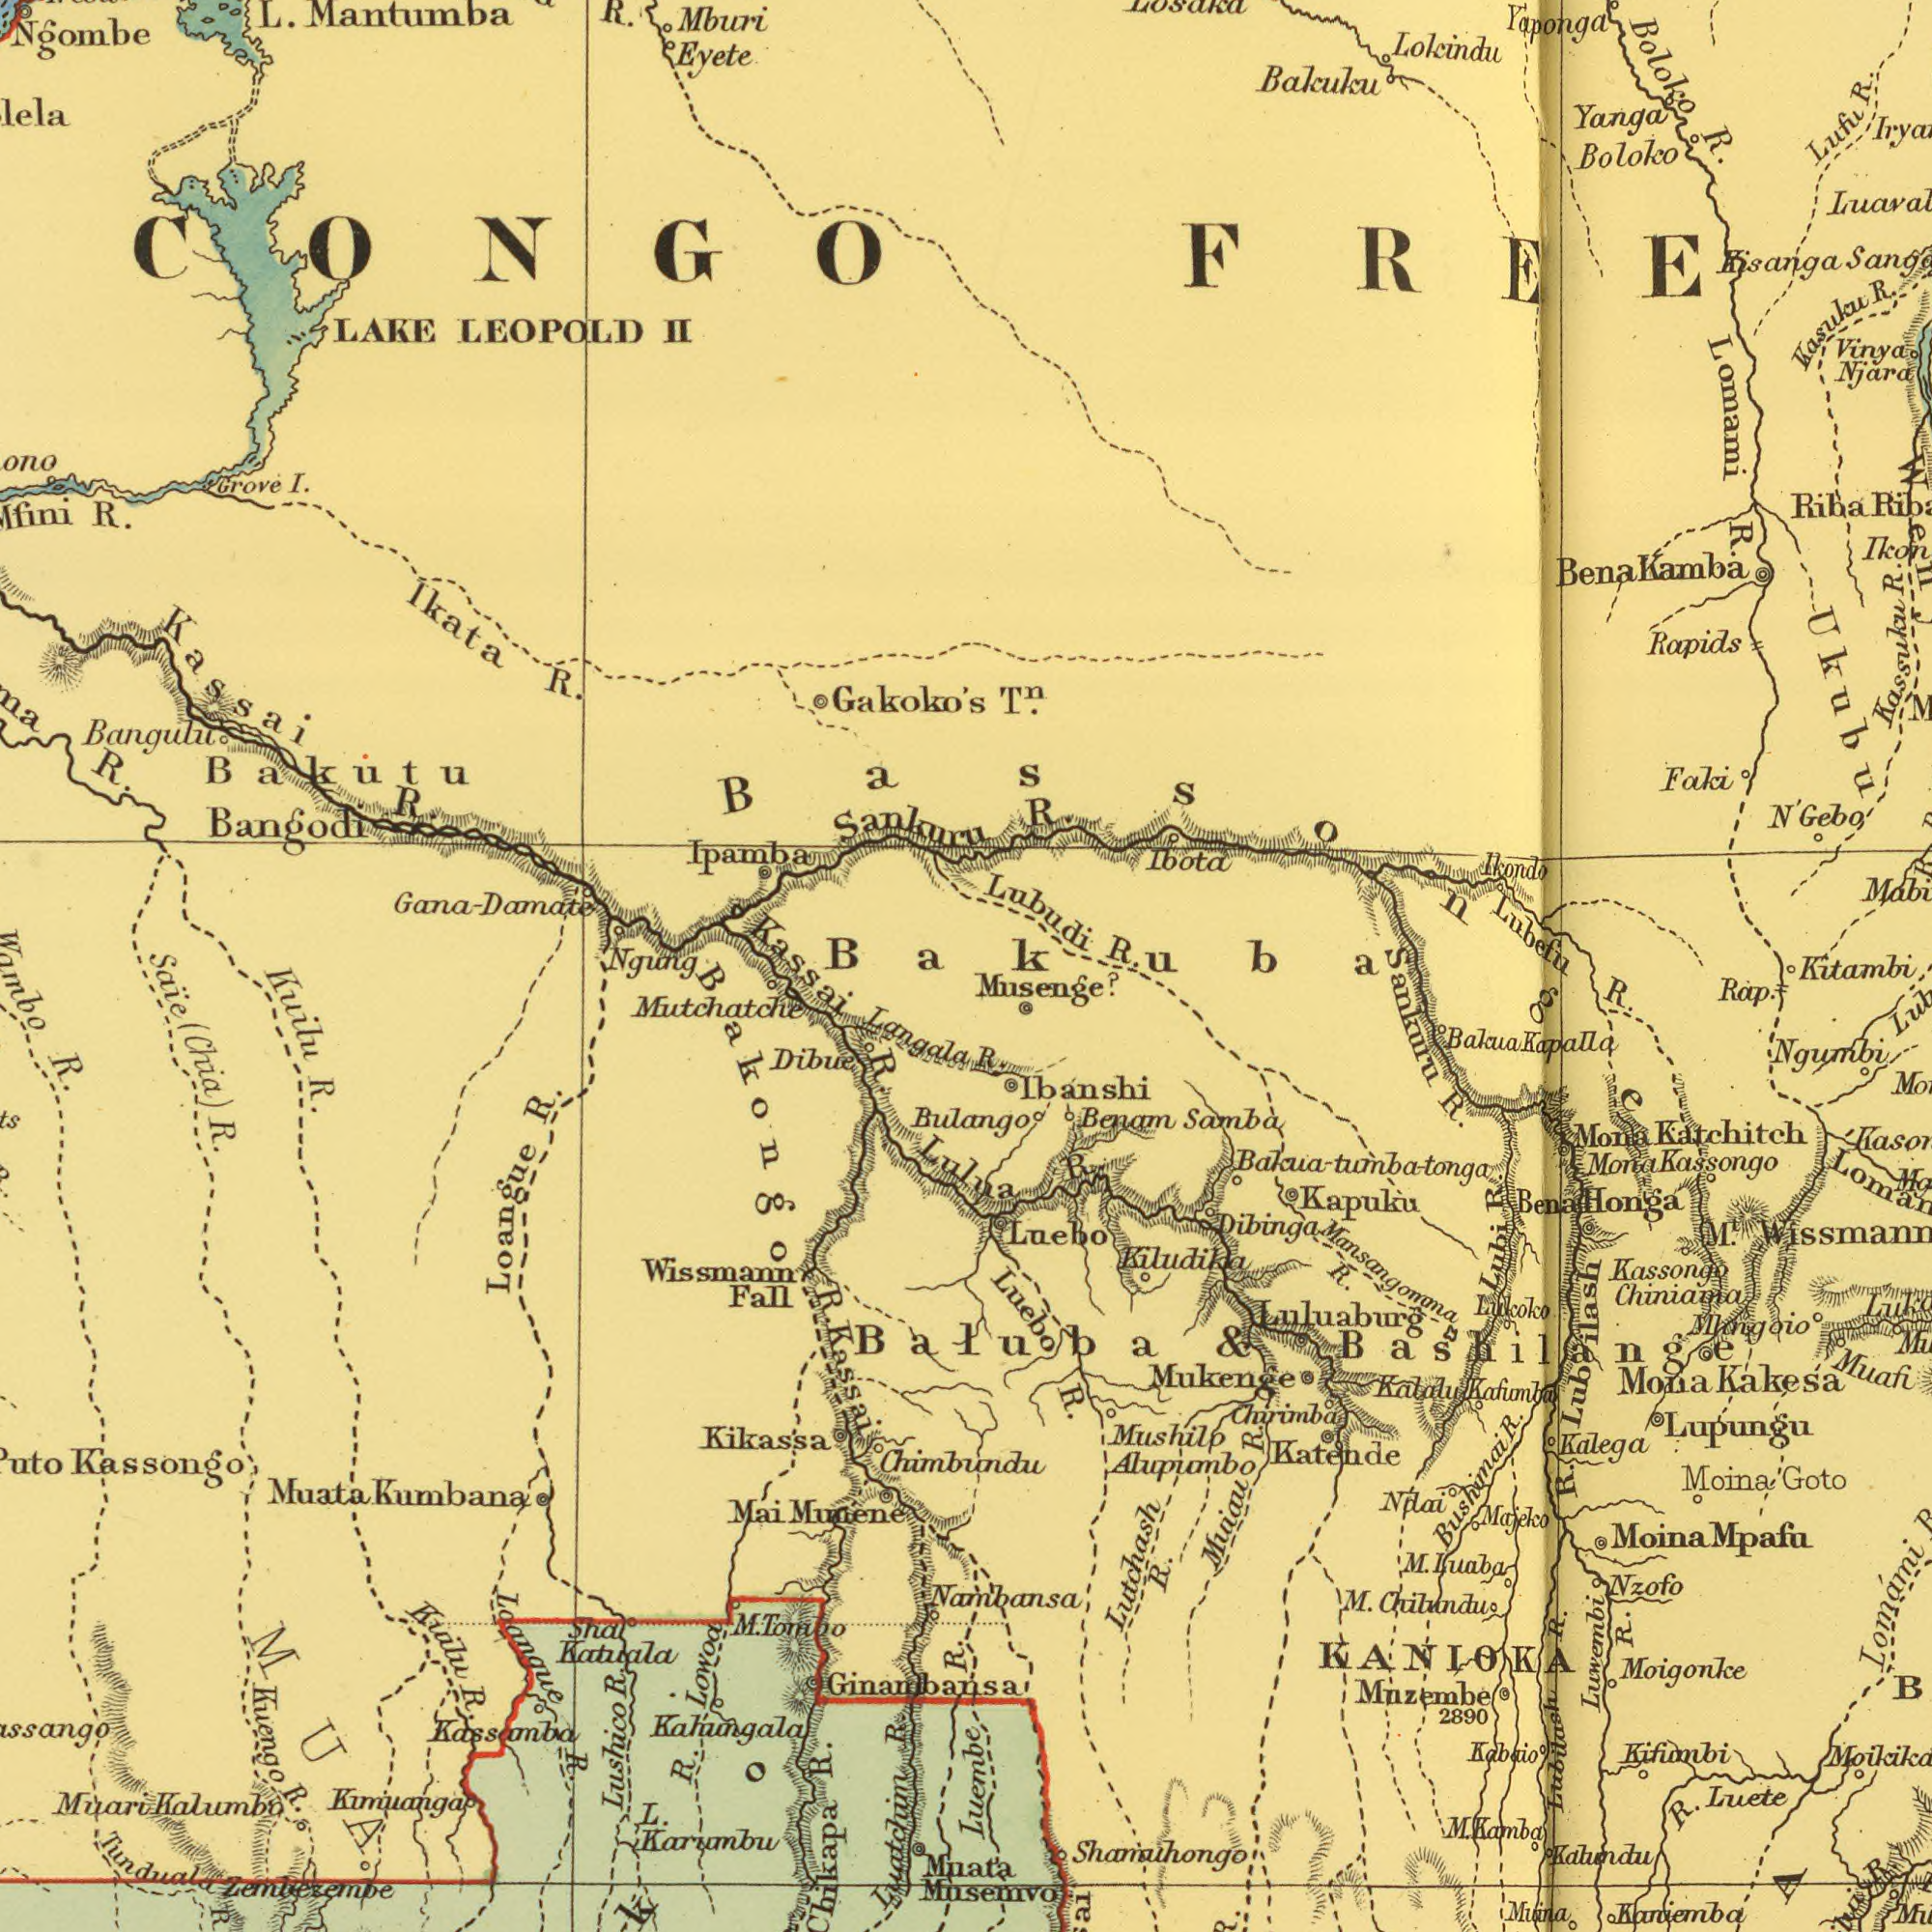What text appears in the top-right area of the image? Lubudi Bakuku Njara R. Rapids Ukubu Boloko Riba Kassuku Bena Ibota Lufu Kasulau Yaponga Ikondo Vinya N' Faki Lubefu Yanga Ikon R. T<sup>n</sup>. Boloko Lomami Lokindu R. R. R. R. R. Kisanga FREE Kamba Bassonge R Bakuba Kitambi Gebo What text can you see in the top-left section? Mantumba LEOPOLD Sankuru R. Bakutu R. LAKE Eyete Mburi Ipamba Gakoko's Bangulu I. Kassai II R. R. L. Kassai Grove R. Bangodi Gana- Ikata Ngombe CONGO Ngung Damate What text is visible in the lower-right corner? Muata Luluaburg Moigonke Shamaihongo Lutchash Chiniama Ibanshi Kakesa Katende Ngumbi Sankuru Lupungu KANIOKA Musenge? Muina Benam Alupumbo Kassongo Samba Chirimba Kifumbi Mazembe Rap. M. Kassongo R. Kapuku Lubi Kabaio Mona Mona Bushimai Lukoko Kaniemba Luwembi Muafi Kalega Kalalu R. M. Kiludika Luaba M<sup>t</sup>. Mosemvo R. R. Muiau Moina R. Luete 2890 Katchitch R. Luebo Honga Kafumba Majeko Luebo Nambansa R. R. Nzofo Ndai Kahmdu Chilundu R. R. Bulango Mpafu Goto Lubilash Mushilp Luembe Mansangomma Mona R. Mukenge Lomami Lubilash R. Kamba Mangoio R. & Baluba Bashilange R. R. M. Moina Dibinga Bakua-tumba-tonga Bena R. Balala Kapalla What text is shown in the bottom-left quadrant? Loanaue Karumbu Zemlezembe R. Langala R. Kuengo Mutchatche R. Kassongo MUA R. Kuilu Munene R. R. R. Klmilanga Kumbana Muari Wissmann Mai Chikapa L. Tunduala R. Kikassa Dibue Lowoa Katuala Chimbundu Ginanbansa R. Kahungala Kalumbo Loangue Kuilu Fall (Chia) Muata Lulua R. Luatchim SaЇe R. R. Kassamba sha R. Bakongo Lushico Kassai R M. Wambo Tonaoo 